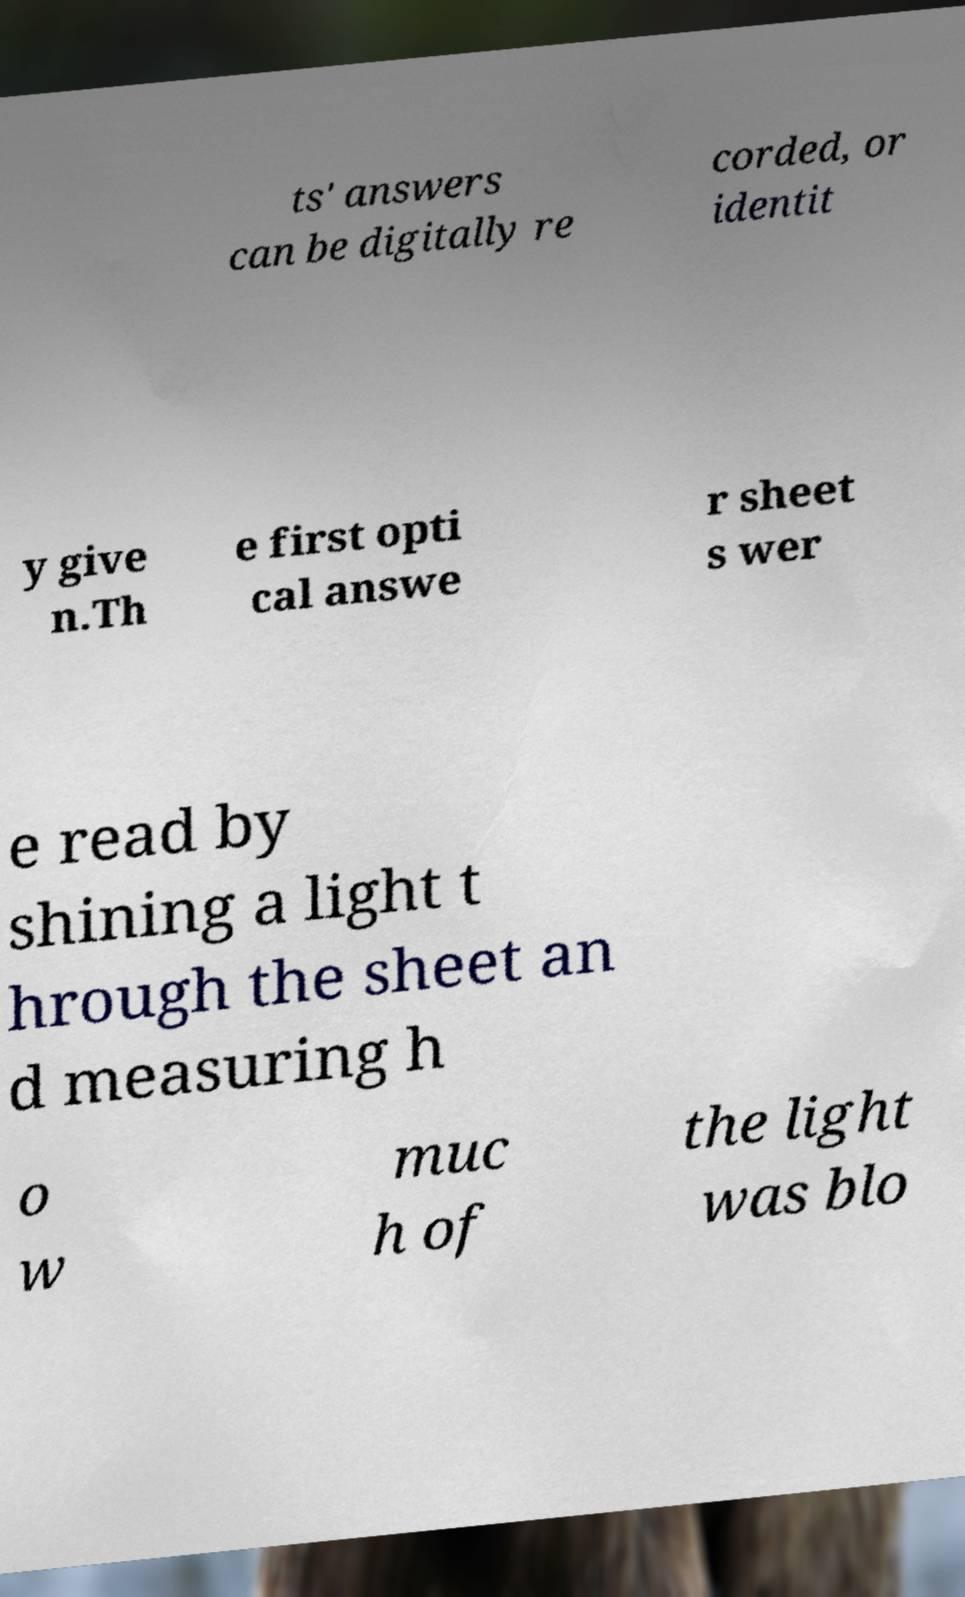Please read and relay the text visible in this image. What does it say? ts' answers can be digitally re corded, or identit y give n.Th e first opti cal answe r sheet s wer e read by shining a light t hrough the sheet an d measuring h o w muc h of the light was blo 